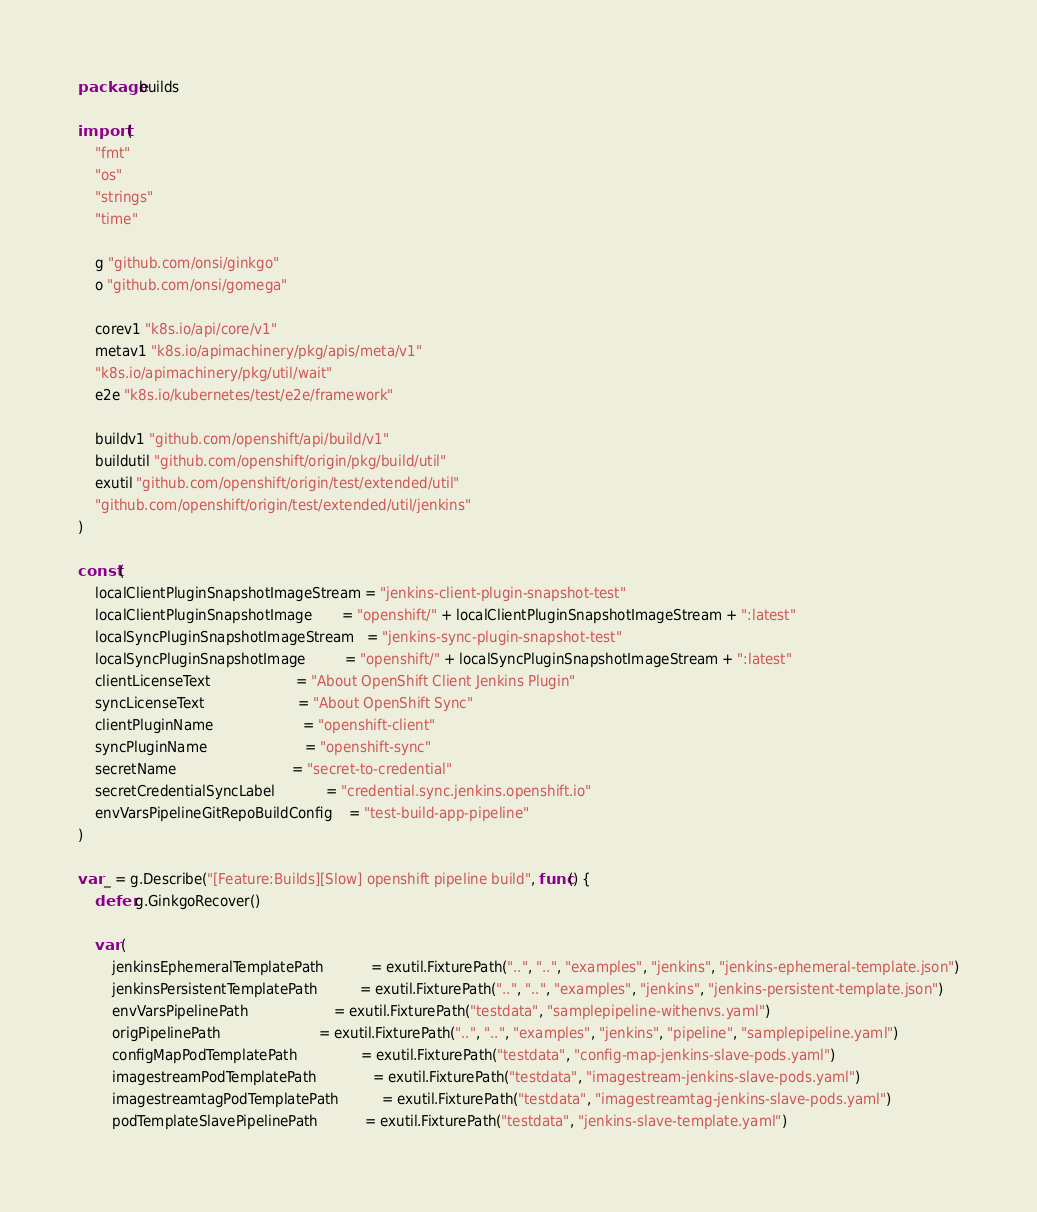<code> <loc_0><loc_0><loc_500><loc_500><_Go_>package builds

import (
	"fmt"
	"os"
	"strings"
	"time"

	g "github.com/onsi/ginkgo"
	o "github.com/onsi/gomega"

	corev1 "k8s.io/api/core/v1"
	metav1 "k8s.io/apimachinery/pkg/apis/meta/v1"
	"k8s.io/apimachinery/pkg/util/wait"
	e2e "k8s.io/kubernetes/test/e2e/framework"

	buildv1 "github.com/openshift/api/build/v1"
	buildutil "github.com/openshift/origin/pkg/build/util"
	exutil "github.com/openshift/origin/test/extended/util"
	"github.com/openshift/origin/test/extended/util/jenkins"
)

const (
	localClientPluginSnapshotImageStream = "jenkins-client-plugin-snapshot-test"
	localClientPluginSnapshotImage       = "openshift/" + localClientPluginSnapshotImageStream + ":latest"
	localSyncPluginSnapshotImageStream   = "jenkins-sync-plugin-snapshot-test"
	localSyncPluginSnapshotImage         = "openshift/" + localSyncPluginSnapshotImageStream + ":latest"
	clientLicenseText                    = "About OpenShift Client Jenkins Plugin"
	syncLicenseText                      = "About OpenShift Sync"
	clientPluginName                     = "openshift-client"
	syncPluginName                       = "openshift-sync"
	secretName                           = "secret-to-credential"
	secretCredentialSyncLabel            = "credential.sync.jenkins.openshift.io"
	envVarsPipelineGitRepoBuildConfig    = "test-build-app-pipeline"
)

var _ = g.Describe("[Feature:Builds][Slow] openshift pipeline build", func() {
	defer g.GinkgoRecover()

	var (
		jenkinsEphemeralTemplatePath           = exutil.FixturePath("..", "..", "examples", "jenkins", "jenkins-ephemeral-template.json")
		jenkinsPersistentTemplatePath          = exutil.FixturePath("..", "..", "examples", "jenkins", "jenkins-persistent-template.json")
		envVarsPipelinePath                    = exutil.FixturePath("testdata", "samplepipeline-withenvs.yaml")
		origPipelinePath                       = exutil.FixturePath("..", "..", "examples", "jenkins", "pipeline", "samplepipeline.yaml")
		configMapPodTemplatePath               = exutil.FixturePath("testdata", "config-map-jenkins-slave-pods.yaml")
		imagestreamPodTemplatePath             = exutil.FixturePath("testdata", "imagestream-jenkins-slave-pods.yaml")
		imagestreamtagPodTemplatePath          = exutil.FixturePath("testdata", "imagestreamtag-jenkins-slave-pods.yaml")
		podTemplateSlavePipelinePath           = exutil.FixturePath("testdata", "jenkins-slave-template.yaml")</code> 